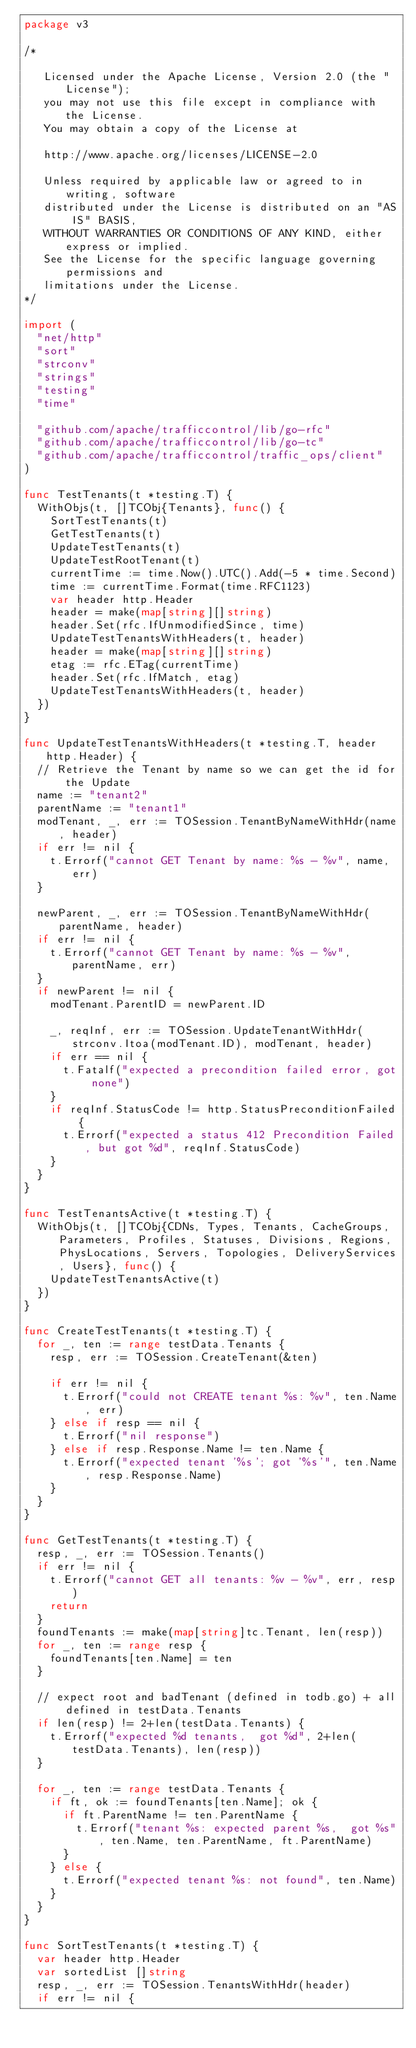<code> <loc_0><loc_0><loc_500><loc_500><_Go_>package v3

/*

   Licensed under the Apache License, Version 2.0 (the "License");
   you may not use this file except in compliance with the License.
   You may obtain a copy of the License at

   http://www.apache.org/licenses/LICENSE-2.0

   Unless required by applicable law or agreed to in writing, software
   distributed under the License is distributed on an "AS IS" BASIS,
   WITHOUT WARRANTIES OR CONDITIONS OF ANY KIND, either express or implied.
   See the License for the specific language governing permissions and
   limitations under the License.
*/

import (
	"net/http"
	"sort"
	"strconv"
	"strings"
	"testing"
	"time"

	"github.com/apache/trafficcontrol/lib/go-rfc"
	"github.com/apache/trafficcontrol/lib/go-tc"
	"github.com/apache/trafficcontrol/traffic_ops/client"
)

func TestTenants(t *testing.T) {
	WithObjs(t, []TCObj{Tenants}, func() {
		SortTestTenants(t)
		GetTestTenants(t)
		UpdateTestTenants(t)
		UpdateTestRootTenant(t)
		currentTime := time.Now().UTC().Add(-5 * time.Second)
		time := currentTime.Format(time.RFC1123)
		var header http.Header
		header = make(map[string][]string)
		header.Set(rfc.IfUnmodifiedSince, time)
		UpdateTestTenantsWithHeaders(t, header)
		header = make(map[string][]string)
		etag := rfc.ETag(currentTime)
		header.Set(rfc.IfMatch, etag)
		UpdateTestTenantsWithHeaders(t, header)
	})
}

func UpdateTestTenantsWithHeaders(t *testing.T, header http.Header) {
	// Retrieve the Tenant by name so we can get the id for the Update
	name := "tenant2"
	parentName := "tenant1"
	modTenant, _, err := TOSession.TenantByNameWithHdr(name, header)
	if err != nil {
		t.Errorf("cannot GET Tenant by name: %s - %v", name, err)
	}

	newParent, _, err := TOSession.TenantByNameWithHdr(parentName, header)
	if err != nil {
		t.Errorf("cannot GET Tenant by name: %s - %v", parentName, err)
	}
	if newParent != nil {
		modTenant.ParentID = newParent.ID

		_, reqInf, err := TOSession.UpdateTenantWithHdr(strconv.Itoa(modTenant.ID), modTenant, header)
		if err == nil {
			t.Fatalf("expected a precondition failed error, got none")
		}
		if reqInf.StatusCode != http.StatusPreconditionFailed {
			t.Errorf("expected a status 412 Precondition Failed, but got %d", reqInf.StatusCode)
		}
	}
}

func TestTenantsActive(t *testing.T) {
	WithObjs(t, []TCObj{CDNs, Types, Tenants, CacheGroups, Parameters, Profiles, Statuses, Divisions, Regions, PhysLocations, Servers, Topologies, DeliveryServices, Users}, func() {
		UpdateTestTenantsActive(t)
	})
}

func CreateTestTenants(t *testing.T) {
	for _, ten := range testData.Tenants {
		resp, err := TOSession.CreateTenant(&ten)

		if err != nil {
			t.Errorf("could not CREATE tenant %s: %v", ten.Name, err)
		} else if resp == nil {
			t.Errorf("nil response")
		} else if resp.Response.Name != ten.Name {
			t.Errorf("expected tenant '%s'; got '%s'", ten.Name, resp.Response.Name)
		}
	}
}

func GetTestTenants(t *testing.T) {
	resp, _, err := TOSession.Tenants()
	if err != nil {
		t.Errorf("cannot GET all tenants: %v - %v", err, resp)
		return
	}
	foundTenants := make(map[string]tc.Tenant, len(resp))
	for _, ten := range resp {
		foundTenants[ten.Name] = ten
	}

	// expect root and badTenant (defined in todb.go) + all defined in testData.Tenants
	if len(resp) != 2+len(testData.Tenants) {
		t.Errorf("expected %d tenants,  got %d", 2+len(testData.Tenants), len(resp))
	}

	for _, ten := range testData.Tenants {
		if ft, ok := foundTenants[ten.Name]; ok {
			if ft.ParentName != ten.ParentName {
				t.Errorf("tenant %s: expected parent %s,  got %s", ten.Name, ten.ParentName, ft.ParentName)
			}
		} else {
			t.Errorf("expected tenant %s: not found", ten.Name)
		}
	}
}

func SortTestTenants(t *testing.T) {
	var header http.Header
	var sortedList []string
	resp, _, err := TOSession.TenantsWithHdr(header)
	if err != nil {</code> 